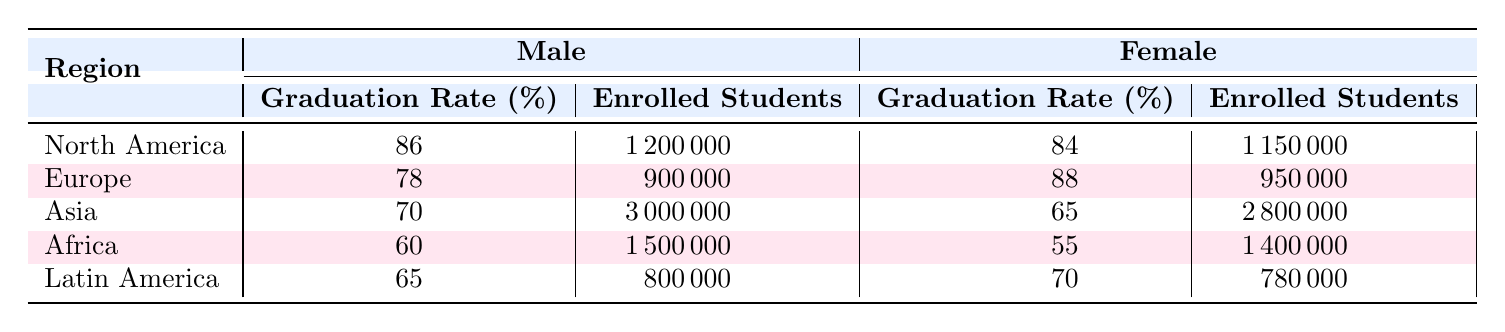What's the graduation rate for females in Europe? The table shows that the graduation rate for females in Europe is 88%.
Answer: 88 Which region has the highest graduation rate for males? By comparing the male graduation rates, North America has the highest graduation rate at 86%.
Answer: North America What is the difference in graduation rates between males and females in Asia? The graduation rate for males in Asia is 70% and for females it is 65%. The difference is 70 - 65 = 5%.
Answer: 5% Is the graduation rate for females in Latin America higher than that for males? The graduation rate for females in Latin America is 70%, while for males it is 65%. Therefore, yes, it is higher.
Answer: Yes What is the average graduation rate for males across all regions? The male graduation rates are 86% (North America), 78% (Europe), 70% (Asia), 60% (Africa), and 65% (Latin America). The average is (86 + 78 + 70 + 60 + 65) / 5 = 71.
Answer: 71.8 What is the total number of enrolled students for females across all regions? The number of enrolled female students is 1,150,000 (North America) + 950,000 (Europe) + 2,800,000 (Asia) + 1,400,000 (Africa) + 780,000 (Latin America). The total is 1,150,000 + 950,000 + 2,800,000 + 1,400,000 + 780,000 = 8,080,000.
Answer: 8,080,000 Which region had the least difference in graduation rates between genders? In Africa, the graduation rates are 60% for males and 55% for females, which is a difference of 5%. Compared to other regions, it's the least difference.
Answer: Africa Are there more enrolled students for males or females in North America? There are 1,200,000 enrolled male students and 1,150,000 enrolled female students in North America. Therefore, there are more male students.
Answer: Males 